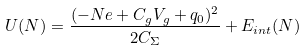Convert formula to latex. <formula><loc_0><loc_0><loc_500><loc_500>U ( N ) = \frac { ( - N e + C _ { g } V _ { g } + q _ { 0 } ) ^ { 2 } } { 2 C _ { \Sigma } } + E _ { i n t } ( N )</formula> 